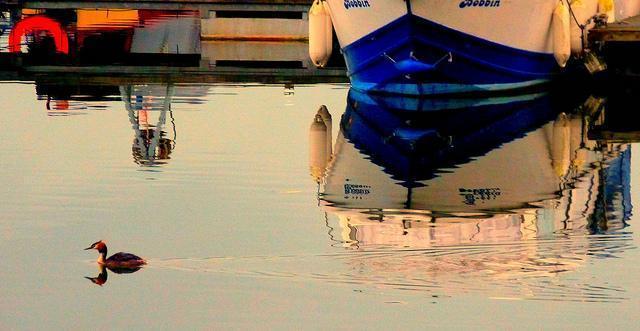How many boats are there?
Give a very brief answer. 1. 